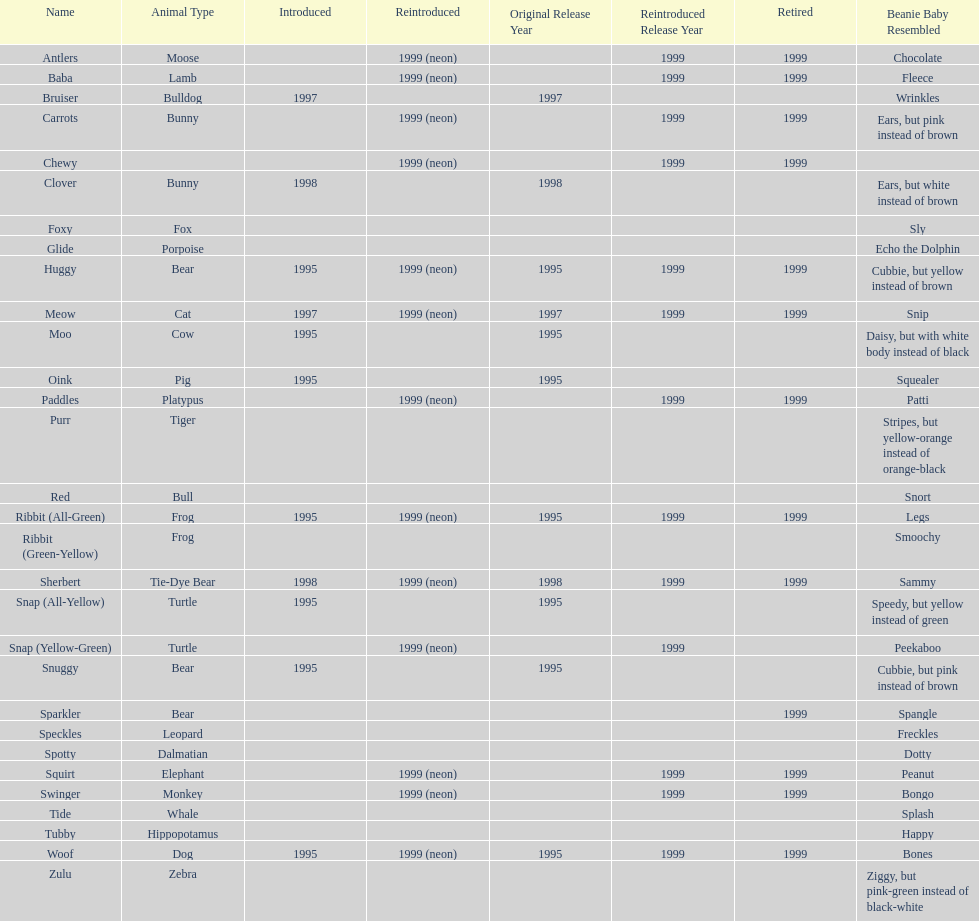Tell me the number of pillow pals reintroduced in 1999. 13. 